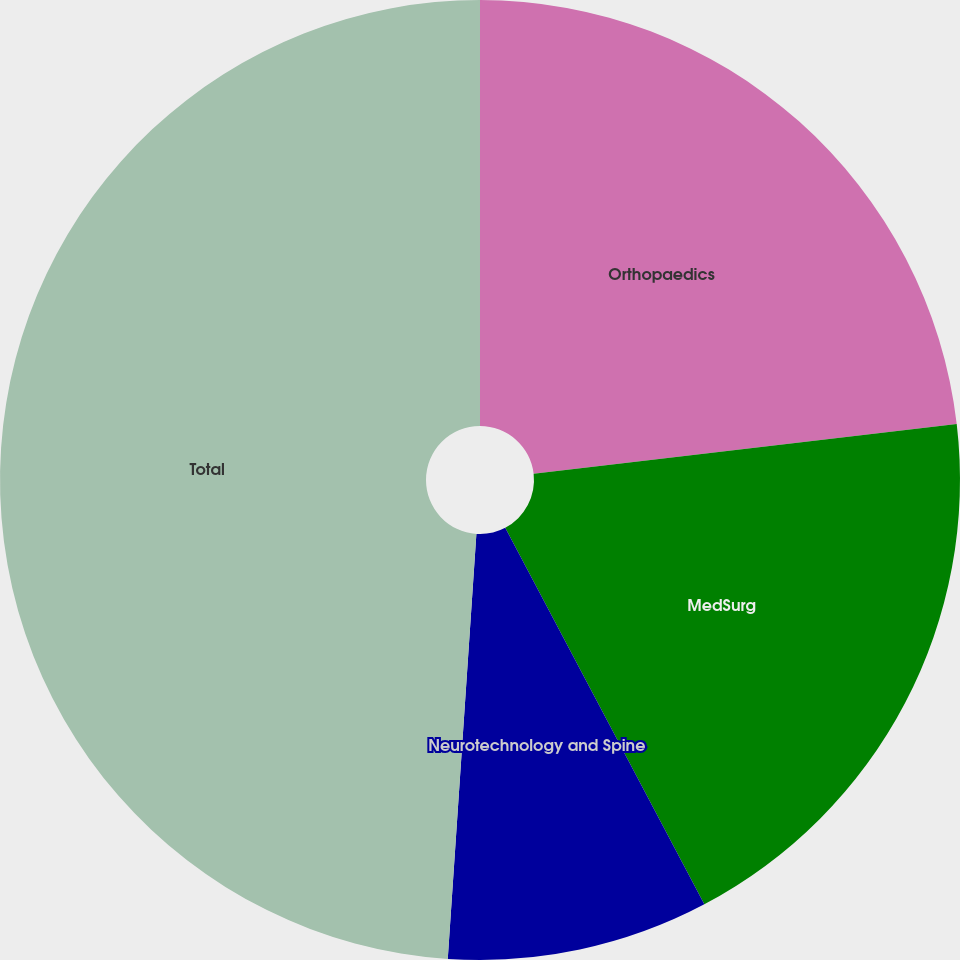Convert chart to OTSL. <chart><loc_0><loc_0><loc_500><loc_500><pie_chart><fcel>Orthopaedics<fcel>MedSurg<fcel>Neurotechnology and Spine<fcel>Total<nl><fcel>23.14%<fcel>19.12%<fcel>8.81%<fcel>48.93%<nl></chart> 